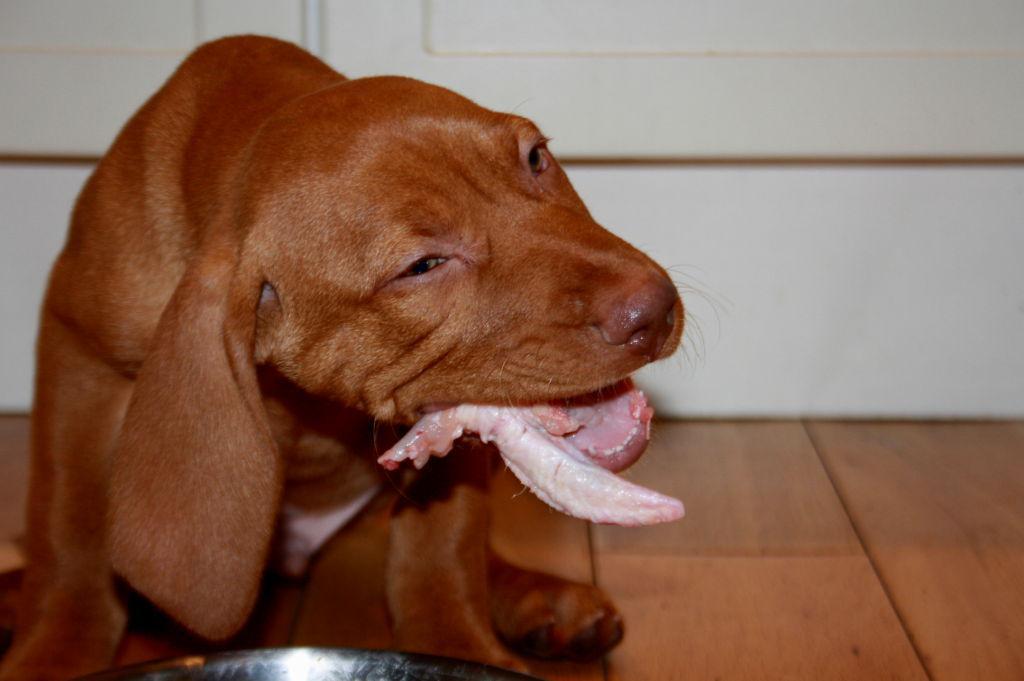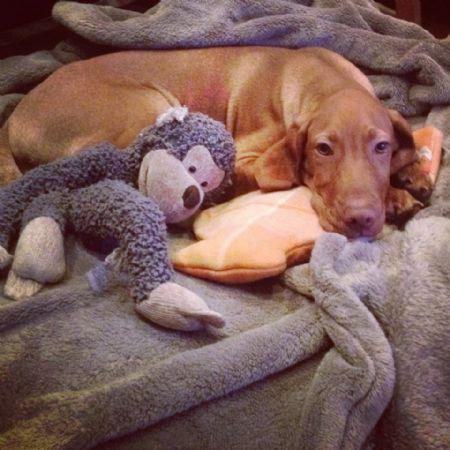The first image is the image on the left, the second image is the image on the right. For the images displayed, is the sentence "The left image contains at least two dogs." factually correct? Answer yes or no. No. The first image is the image on the left, the second image is the image on the right. Evaluate the accuracy of this statement regarding the images: "there are two dogs in the image pair". Is it true? Answer yes or no. Yes. 